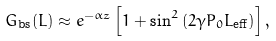Convert formula to latex. <formula><loc_0><loc_0><loc_500><loc_500>G _ { \text {bs} } ( L ) \approx e ^ { - \alpha z } \left [ 1 + \sin ^ { 2 } { ( 2 \gamma P _ { 0 } L _ { \text {eff} } ) } \right ] ,</formula> 